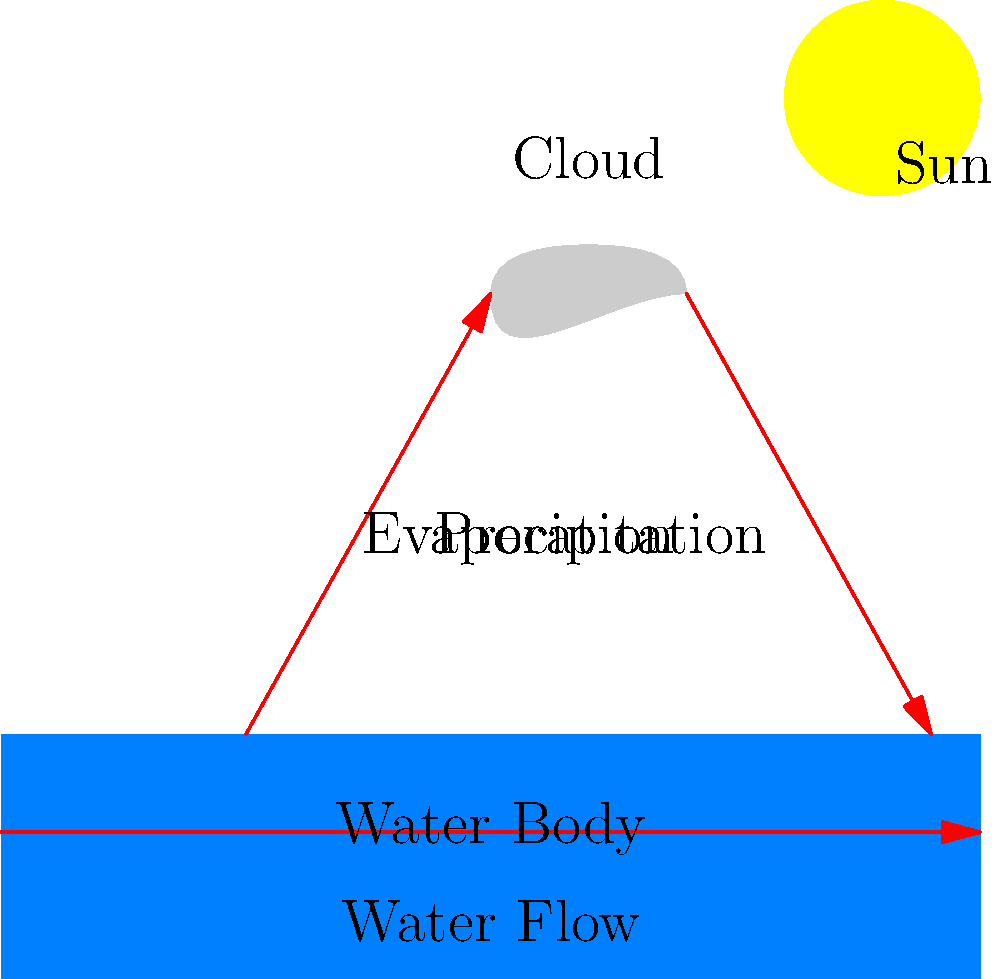Based on the water cycle diagram, which process is most likely to be intensified during summer in Japan, potentially leading to increased rainfall? To answer this question, let's analyze the water cycle diagram and consider the seasonal changes in Japan:

1. The diagram shows three main processes of the water cycle:
   a) Evaporation: water rising from the water body to form clouds
   b) Precipitation: water falling from clouds back to the surface
   c) Water flow: movement of water along the surface

2. In summer, Japan experiences higher temperatures due to increased solar radiation.

3. The sun in the diagram represents the heat source that drives the water cycle.

4. Higher temperatures lead to increased evaporation rates from water bodies.

5. More evaporation results in more water vapor in the atmosphere, which can form more clouds.

6. With more moisture in the air and more cloud formation, there's a higher potential for precipitation.

7. In Japan, this often manifests as the summer rainy season known as "tsuyu" or the East Asian monsoon.

8. Therefore, the process most likely to be intensified during summer in Japan is evaporation, which leads to increased potential for precipitation.

This cycle of increased evaporation and precipitation is a key feature of Japan's summer climate, contrasting with the more stable climate of tropical countries that don't experience distinct seasons.
Answer: Evaporation 